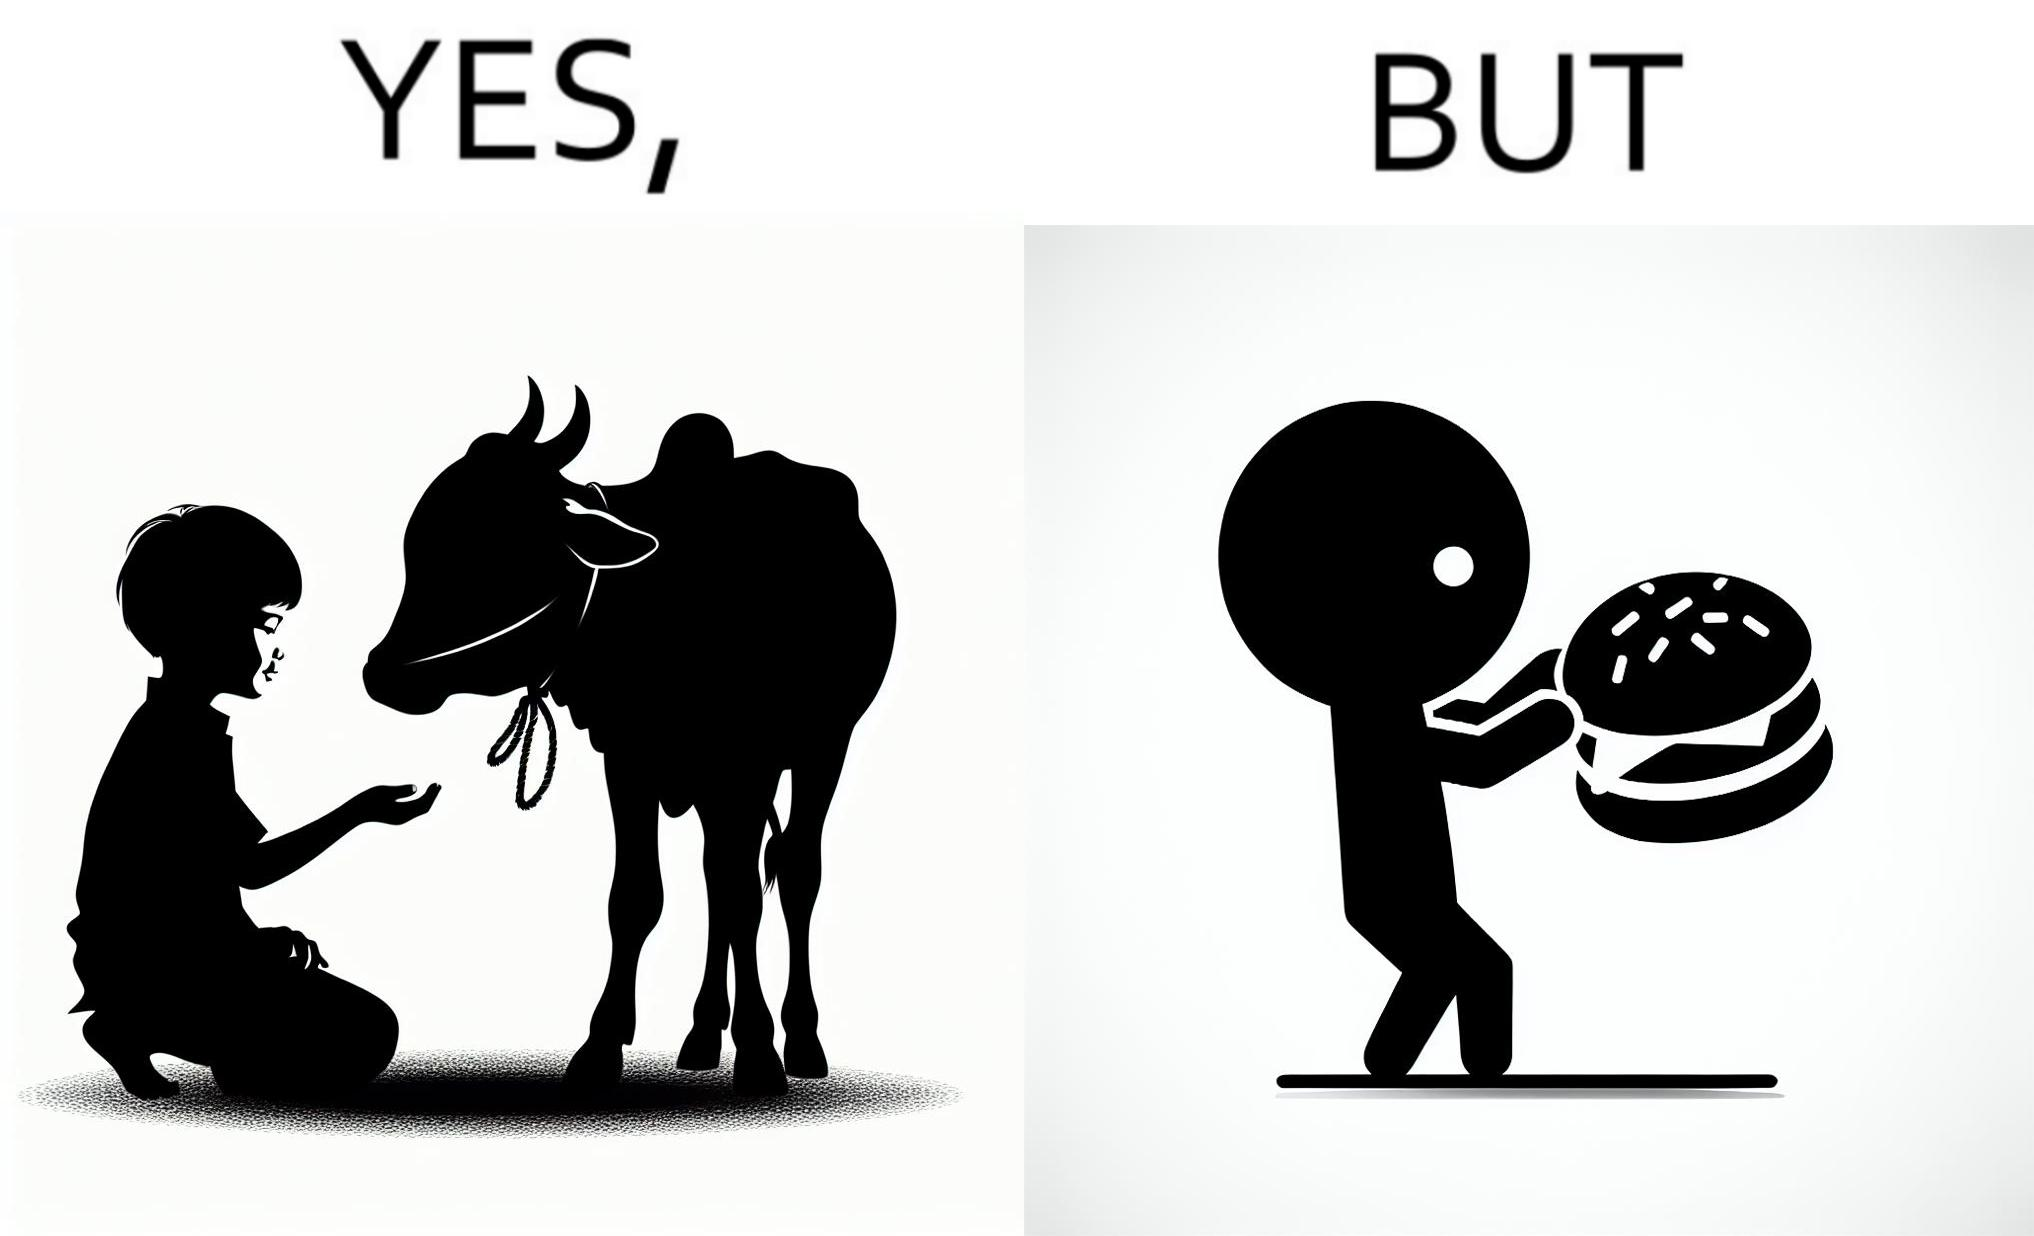Is there satirical content in this image? Yes, this image is satirical. 